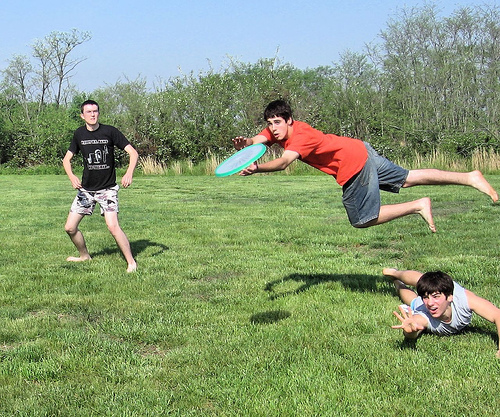Describe what each boy might be feeling right now. The boy jumping to catch the frisbee might feel exhilarated and focused, determined to make the perfect catch. The boy diving to the ground could be feeling eager and competitive, pushing himself to make the play. The boy standing might feel relaxed yet engaged, enjoying the game and ready to jump into action at any moment. What might they do if it starts raining suddenly? If it starts raining suddenly, the boys might laugh and try to continue their game for a few moments, enjoying the spontaneous adventure. However, they would likely soon decide to seek shelter, running to a nearby tree or pavilion to keep dry. They might sit and wait for the rain to pass, or decide to head home to change into dry clothes and continue their fun indoors with some games or a movie. 